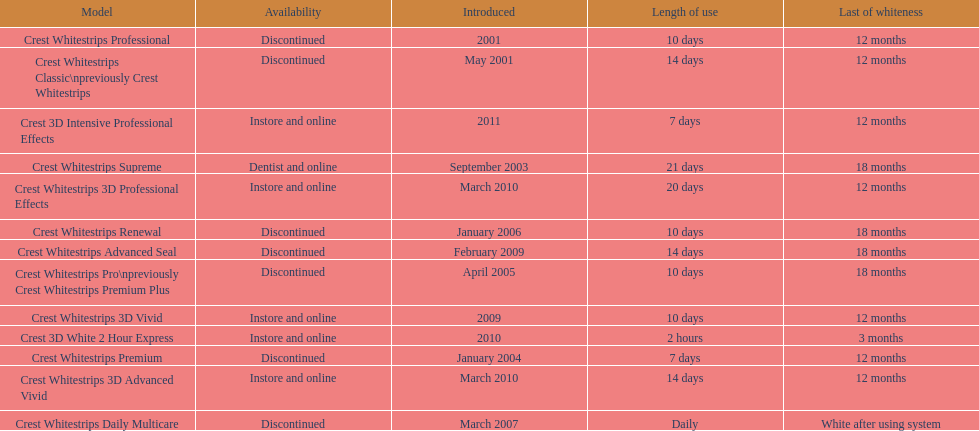What were the models of crest whitestrips? Crest Whitestrips Classic\npreviously Crest Whitestrips, Crest Whitestrips Professional, Crest Whitestrips Supreme, Crest Whitestrips Premium, Crest Whitestrips Pro\npreviously Crest Whitestrips Premium Plus, Crest Whitestrips Renewal, Crest Whitestrips Daily Multicare, Crest Whitestrips Advanced Seal, Crest Whitestrips 3D Vivid, Crest Whitestrips 3D Advanced Vivid, Crest Whitestrips 3D Professional Effects, Crest 3D White 2 Hour Express, Crest 3D Intensive Professional Effects. When were they introduced? May 2001, 2001, September 2003, January 2004, April 2005, January 2006, March 2007, February 2009, 2009, March 2010, March 2010, 2010, 2011. And what is their availability? Discontinued, Discontinued, Dentist and online, Discontinued, Discontinued, Discontinued, Discontinued, Discontinued, Instore and online, Instore and online, Instore and online, Instore and online, Instore and online. Along crest whitestrips 3d vivid, which discontinued model was released in 2009? Crest Whitestrips Advanced Seal. 